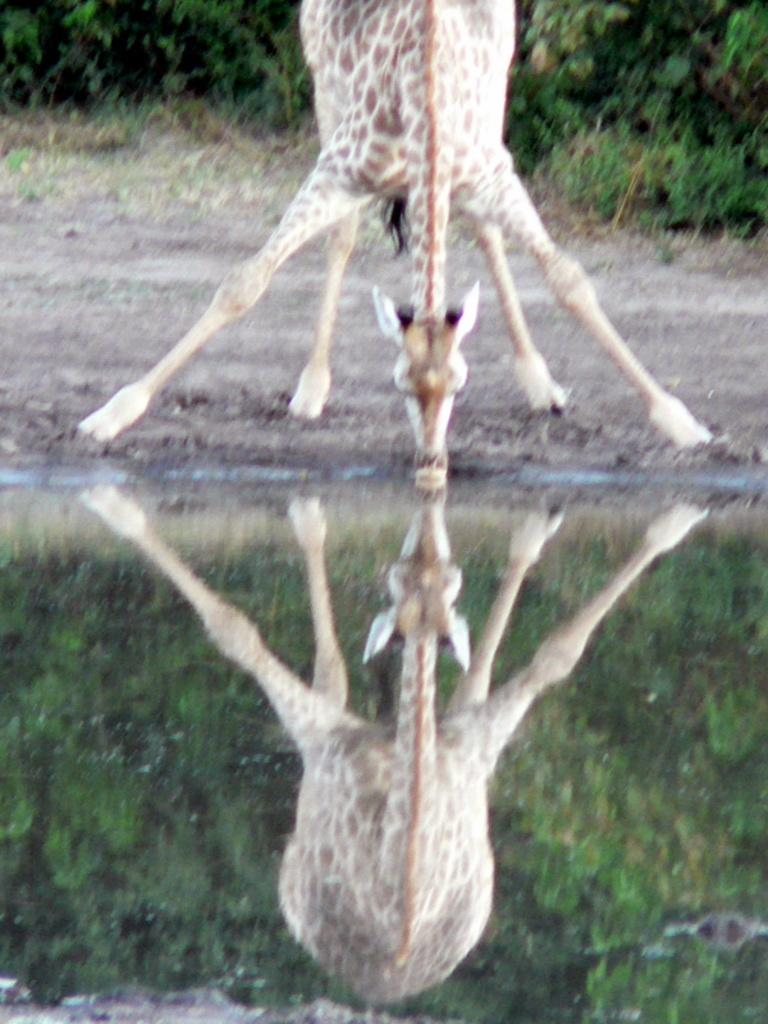What is present in the image that can be seen reflecting something? There is water in the image that reflects an animal and trees. What type of animal is reflected in the water? The animal reflected in the water is not specified in the facts, but it is present in the image. What else can be seen in the background of the image? There are trees in the background of the image. What type of tax is being discussed in the image? There is no mention of tax or any discussion in the image; it primarily features water, an animal, trees, and their reflections. 